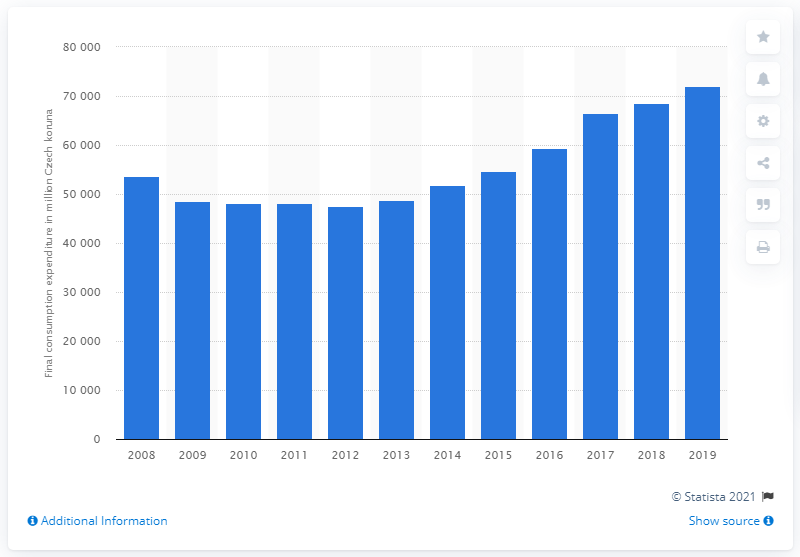Draw attention to some important aspects in this diagram. In 2019, a total of 72,137 Czech koruna was spent on clothing. 